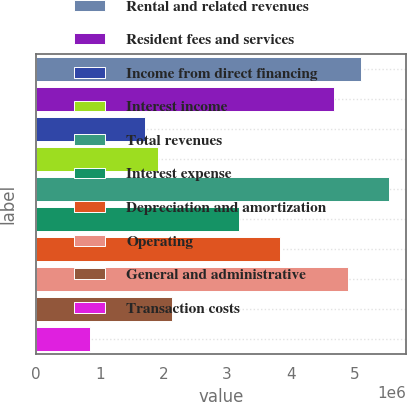Convert chart to OTSL. <chart><loc_0><loc_0><loc_500><loc_500><bar_chart><fcel>Rental and related revenues<fcel>Resident fees and services<fcel>Income from direct financing<fcel>Interest income<fcel>Total revenues<fcel>Interest expense<fcel>Depreciation and amortization<fcel>Operating<fcel>General and administrative<fcel>Transaction costs<nl><fcel>5.1103e+06<fcel>4.68445e+06<fcel>1.70344e+06<fcel>1.91636e+06<fcel>5.53616e+06<fcel>3.19394e+06<fcel>3.83273e+06<fcel>4.89738e+06<fcel>2.12929e+06<fcel>851718<nl></chart> 